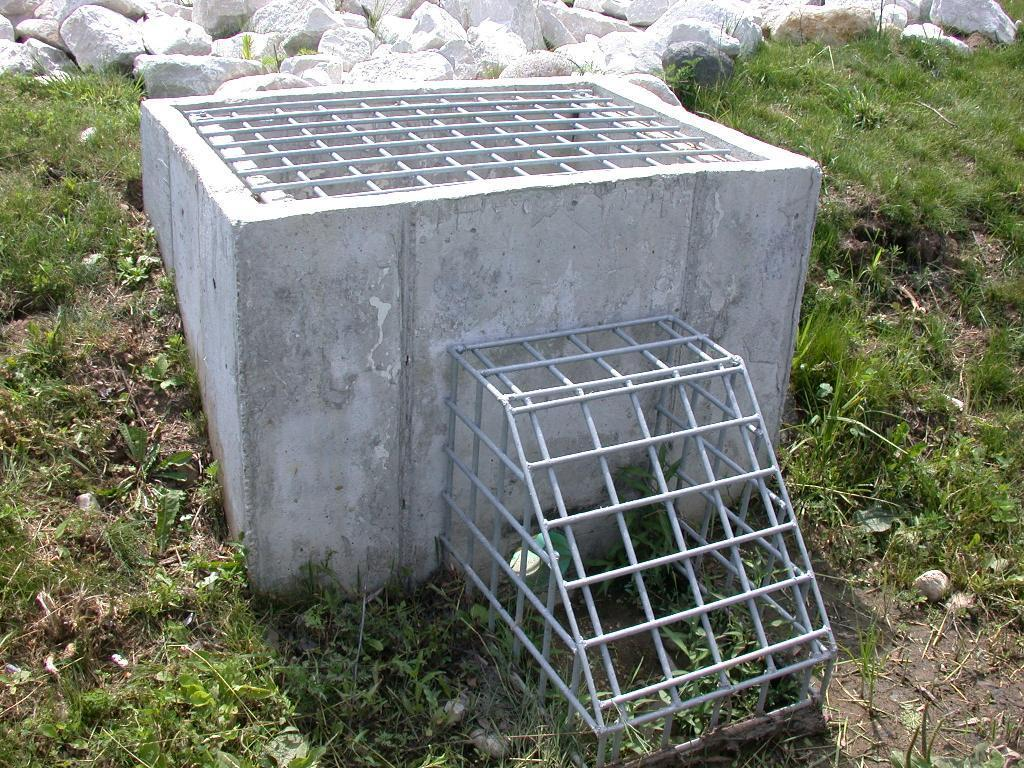What is the main structure in the foreground of the image? There is a well-like structure in the foreground of the image. What can be seen on the structure? The structure has rods on it. What type of vegetation is present around the structure? There is grass around the structure. What else can be found around the structure? There are rocks around the structure. Can you see the toes of the person who kicked the underwear in the image? There is no person or underwear present in the image, so it is not possible to see any toes or the act of kicking. 